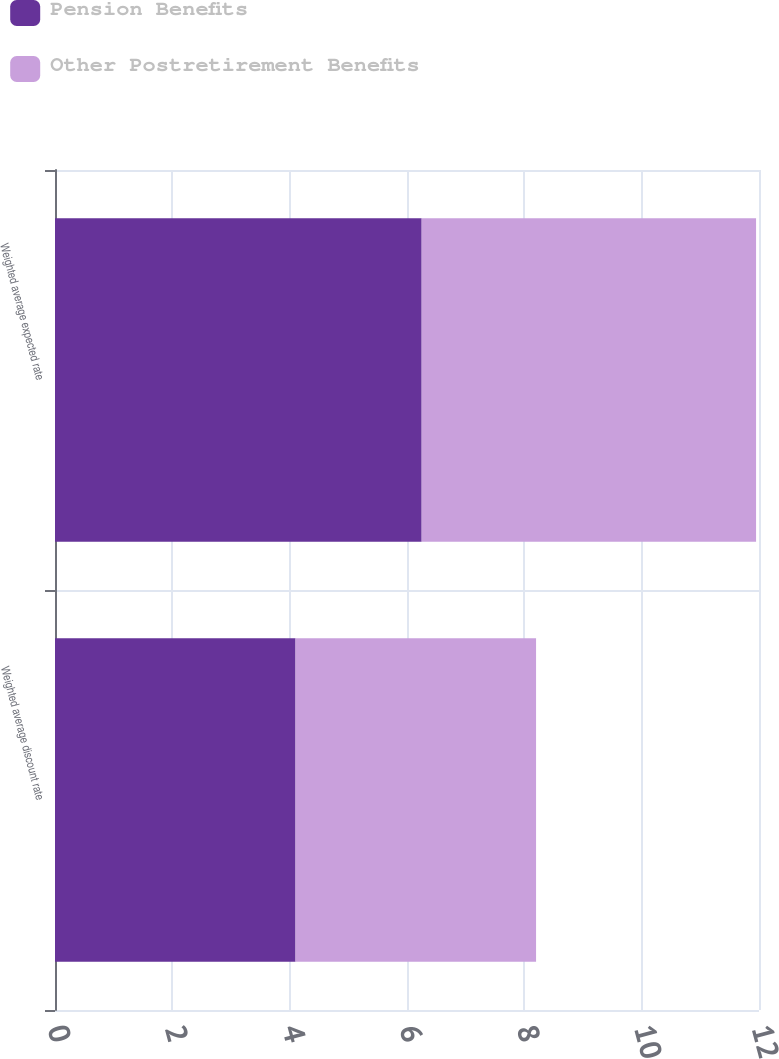Convert chart. <chart><loc_0><loc_0><loc_500><loc_500><stacked_bar_chart><ecel><fcel>Weighted average discount rate<fcel>Weighted average expected rate<nl><fcel>Pension Benefits<fcel>4.1<fcel>6.25<nl><fcel>Other Postretirement Benefits<fcel>4.1<fcel>5.7<nl></chart> 